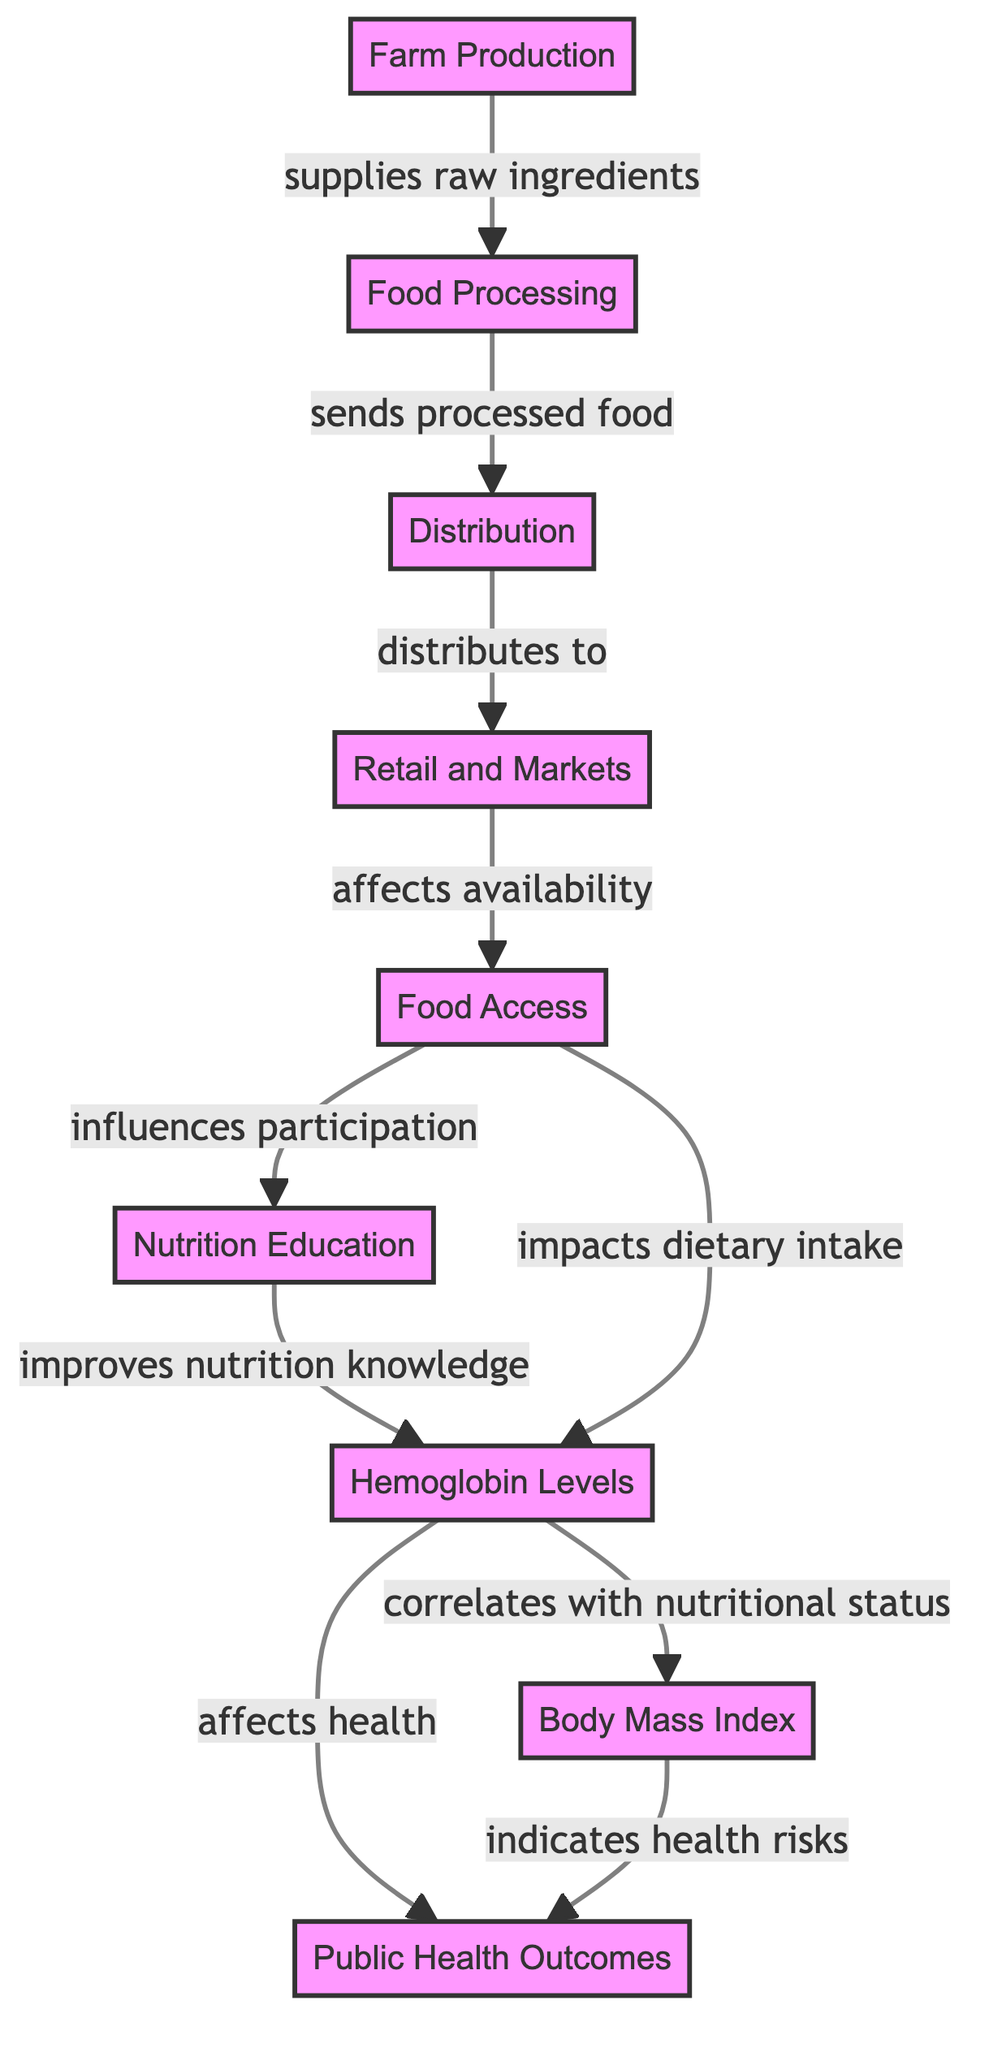What is the first step in the food chain? The first step in the food chain is Farm Production, which initiates the process by supplying raw ingredients.
Answer: Farm Production How many nodes are present in the diagram? The diagram contains a total of eight nodes, representing different stages and outcomes in the food chain.
Answer: Eight What does the 'Distribution' node affect? The 'Distribution' node directly affects the 'Retail and Markets' node by distributing processed food to it.
Answer: Retail and Markets Which node indicates health risks? The Body Mass Index (BMI) node indicates health risks associated with nutritional status and health outcomes.
Answer: Body Mass Index How does Nutrition Education impact hemoglobin levels? Nutrition Education improves nutrition knowledge, which correlates with hemoglobin levels, influencing nutritional outcomes overall.
Answer: Improves nutrition knowledge What correlates with nutritional status in this chain? Hemoglobin levels correlate with nutritional status as they reflect the quality of food intake and overall health.
Answer: Hemoglobin levels Which nodes are influenced by Food Access? Food Access influences both participation in Nutrition Education and dietary intake, creating a bridge between access and educational outcomes.
Answer: Participation in Nutrition Education and dietary intake What is the final outcome linked to Body Mass Index? The final outcome linked to Body Mass Index is public health outcomes, which are determined based on health risks indicated by BMI levels.
Answer: Public Health Outcomes How are hemoglobin levels affected by food access? Hemoglobin levels are impacted through food access as it directly influences dietary intake, leading to improved nutrition that supports better hemoglobin levels.
Answer: Impacts dietary intake 